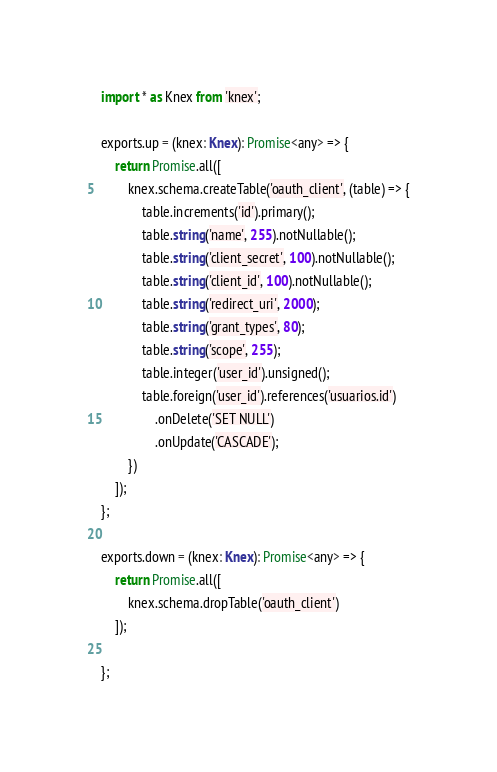<code> <loc_0><loc_0><loc_500><loc_500><_TypeScript_>import * as Knex from 'knex';

exports.up = (knex: Knex): Promise<any> => {
    return Promise.all([
        knex.schema.createTable('oauth_client', (table) => {
            table.increments('id').primary();
            table.string('name', 255).notNullable();
            table.string('client_secret', 100).notNullable();
            table.string('client_id', 100).notNullable();
            table.string('redirect_uri', 2000);
            table.string('grant_types', 80);
            table.string('scope', 255);
            table.integer('user_id').unsigned();
            table.foreign('user_id').references('usuarios.id')
                .onDelete('SET NULL')
                .onUpdate('CASCADE');
        })
    ]);
};

exports.down = (knex: Knex): Promise<any> => {
    return Promise.all([
        knex.schema.dropTable('oauth_client')
    ]);

};
</code> 